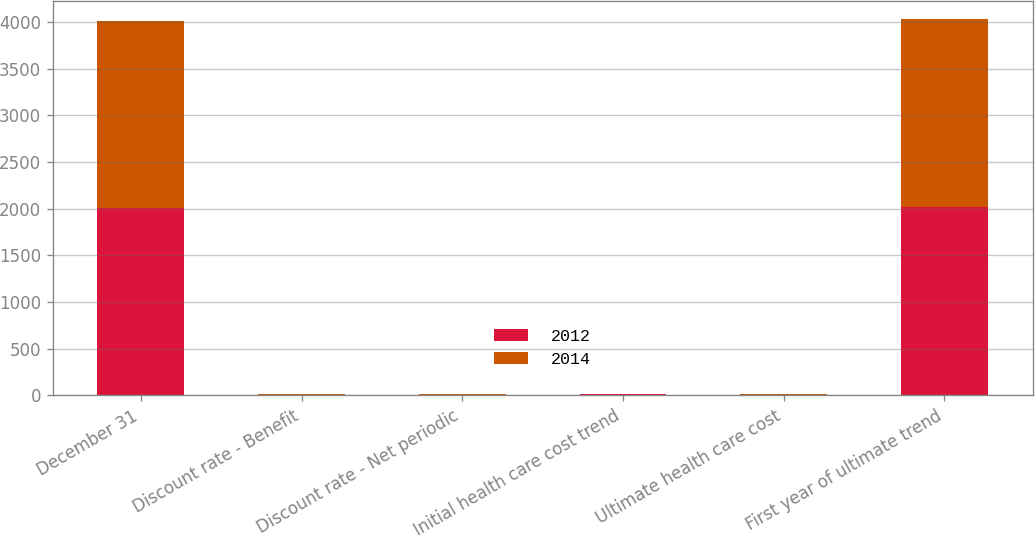Convert chart to OTSL. <chart><loc_0><loc_0><loc_500><loc_500><stacked_bar_chart><ecel><fcel>December 31<fcel>Discount rate - Benefit<fcel>Discount rate - Net periodic<fcel>Initial health care cost trend<fcel>Ultimate health care cost<fcel>First year of ultimate trend<nl><fcel>2012<fcel>2004<fcel>6.25<fcel>6.75<fcel>9.5<fcel>5<fcel>2014<nl><fcel>2014<fcel>2003<fcel>6.75<fcel>7<fcel>9<fcel>5<fcel>2012<nl></chart> 